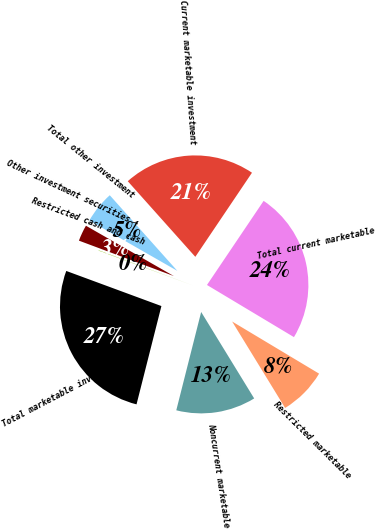Convert chart to OTSL. <chart><loc_0><loc_0><loc_500><loc_500><pie_chart><fcel>Current marketable investment<fcel>Total current marketable<fcel>Restricted marketable<fcel>Noncurrent marketable<fcel>Total marketable investment<fcel>Restricted cash and cash<fcel>Other investment securities -<fcel>Total other investment<nl><fcel>21.04%<fcel>24.16%<fcel>7.65%<fcel>12.7%<fcel>26.68%<fcel>0.06%<fcel>2.59%<fcel>5.12%<nl></chart> 